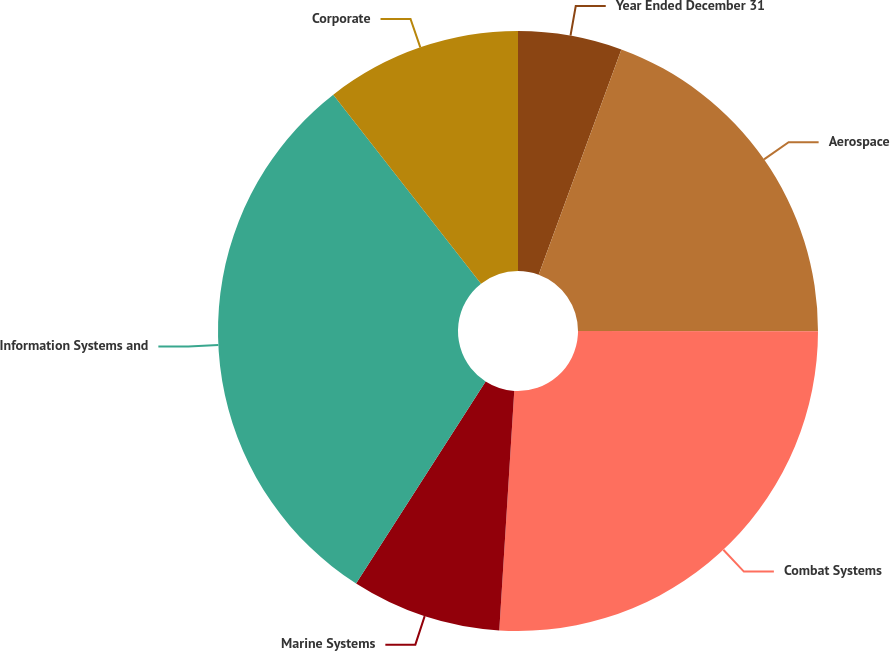<chart> <loc_0><loc_0><loc_500><loc_500><pie_chart><fcel>Year Ended December 31<fcel>Aerospace<fcel>Combat Systems<fcel>Marine Systems<fcel>Information Systems and<fcel>Corporate<nl><fcel>5.6%<fcel>19.41%<fcel>25.99%<fcel>8.08%<fcel>30.37%<fcel>10.56%<nl></chart> 